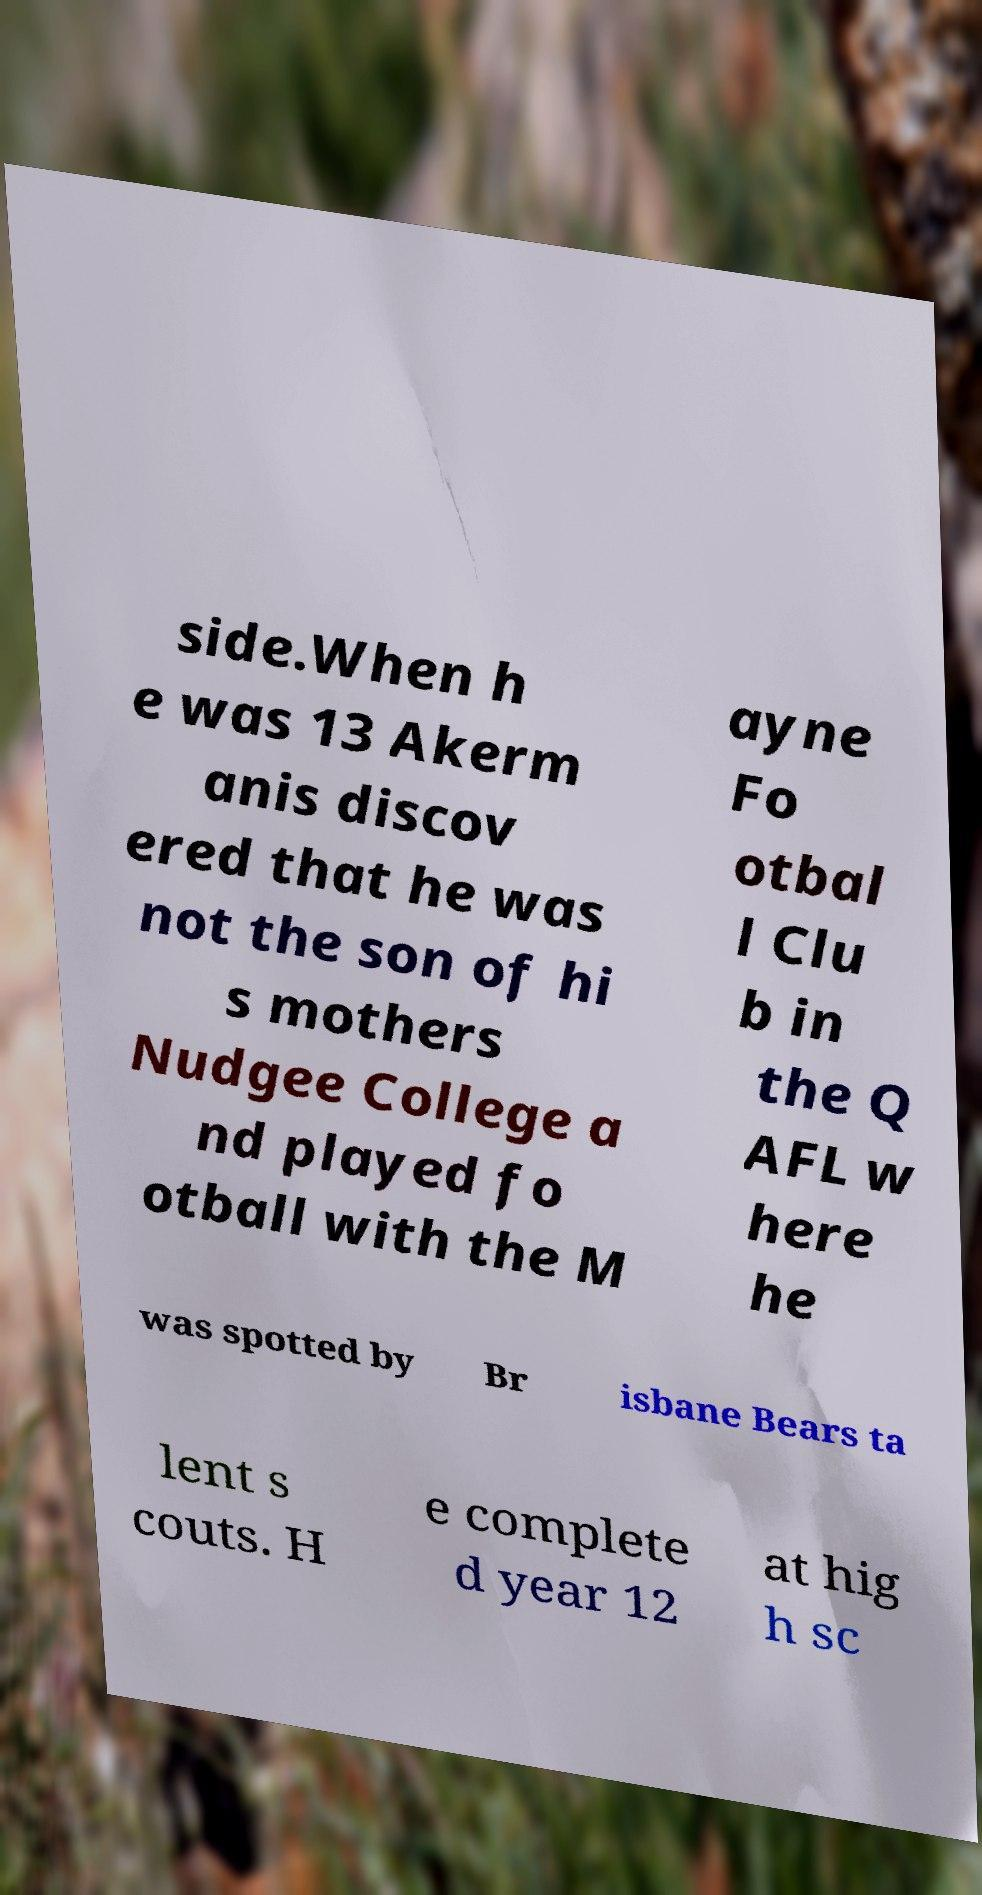Could you extract and type out the text from this image? side.When h e was 13 Akerm anis discov ered that he was not the son of hi s mothers Nudgee College a nd played fo otball with the M ayne Fo otbal l Clu b in the Q AFL w here he was spotted by Br isbane Bears ta lent s couts. H e complete d year 12 at hig h sc 